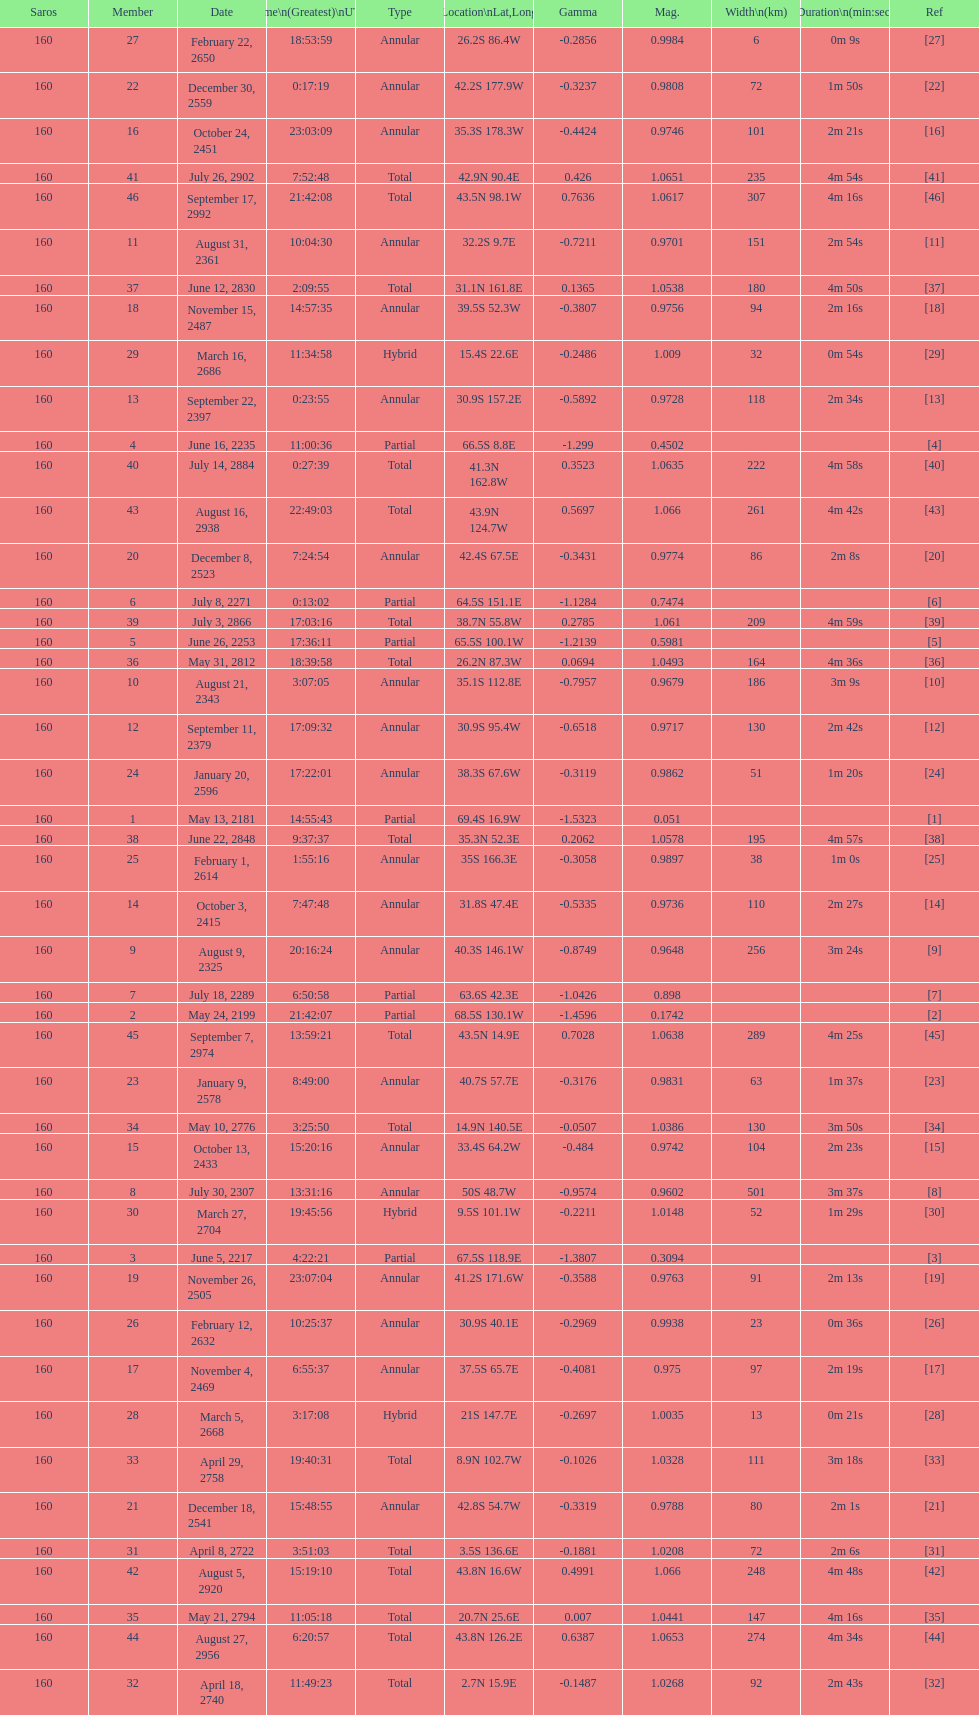How long did 18 last? 2m 16s. 